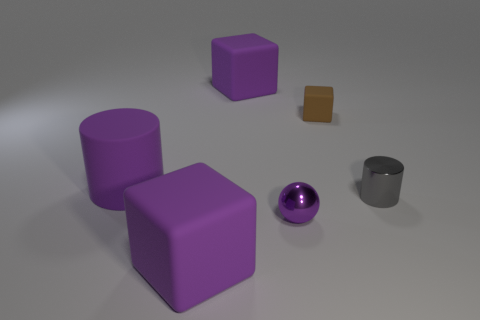Subtract all brown cubes. Subtract all cyan balls. How many cubes are left? 2 Add 4 small rubber things. How many objects exist? 10 Subtract all balls. How many objects are left? 5 Subtract all tiny gray cylinders. Subtract all rubber things. How many objects are left? 1 Add 3 cylinders. How many cylinders are left? 5 Add 2 tiny shiny balls. How many tiny shiny balls exist? 3 Subtract 0 yellow cylinders. How many objects are left? 6 